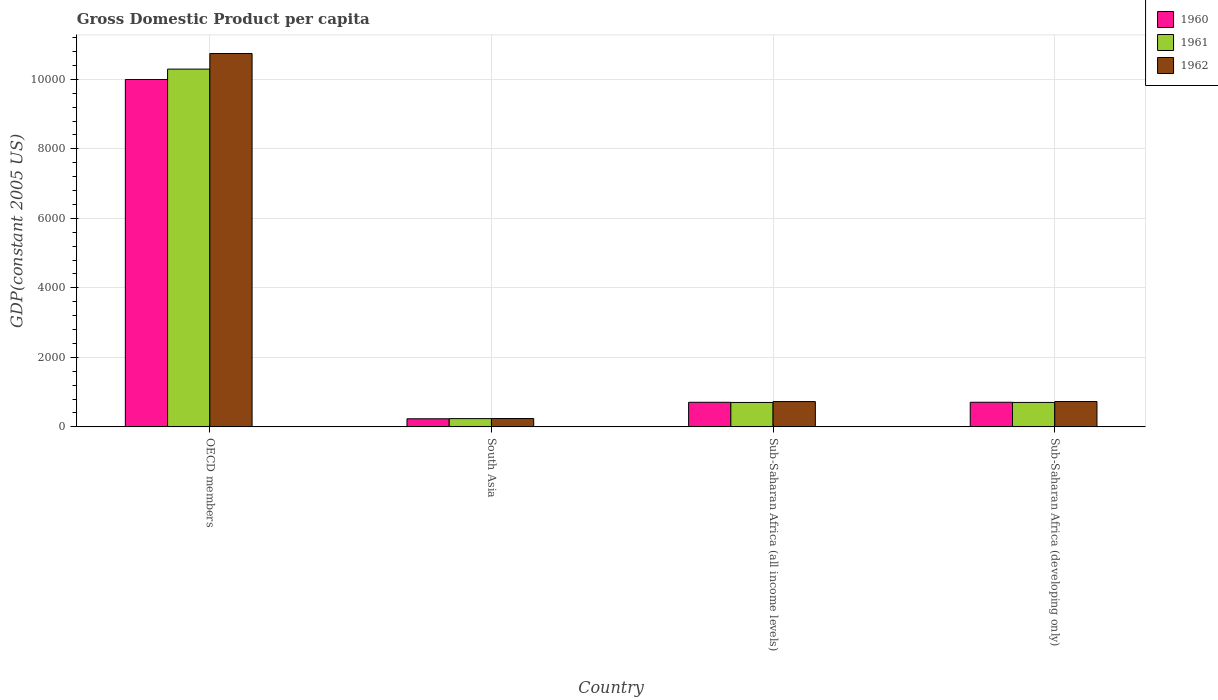Are the number of bars per tick equal to the number of legend labels?
Offer a terse response. Yes. How many bars are there on the 2nd tick from the right?
Provide a short and direct response. 3. In how many cases, is the number of bars for a given country not equal to the number of legend labels?
Provide a short and direct response. 0. What is the GDP per capita in 1962 in OECD members?
Keep it short and to the point. 1.07e+04. Across all countries, what is the maximum GDP per capita in 1962?
Offer a very short reply. 1.07e+04. Across all countries, what is the minimum GDP per capita in 1960?
Provide a short and direct response. 232.78. In which country was the GDP per capita in 1960 minimum?
Provide a succinct answer. South Asia. What is the total GDP per capita in 1960 in the graph?
Your answer should be very brief. 1.16e+04. What is the difference between the GDP per capita in 1962 in South Asia and that in Sub-Saharan Africa (all income levels)?
Your response must be concise. -488. What is the difference between the GDP per capita in 1962 in Sub-Saharan Africa (all income levels) and the GDP per capita in 1960 in South Asia?
Provide a short and direct response. 495.37. What is the average GDP per capita in 1960 per country?
Provide a succinct answer. 2910.89. What is the difference between the GDP per capita of/in 1960 and GDP per capita of/in 1962 in South Asia?
Your response must be concise. -7.37. In how many countries, is the GDP per capita in 1960 greater than 6000 US$?
Your answer should be very brief. 1. What is the ratio of the GDP per capita in 1962 in OECD members to that in South Asia?
Your answer should be very brief. 44.73. Is the difference between the GDP per capita in 1960 in OECD members and South Asia greater than the difference between the GDP per capita in 1962 in OECD members and South Asia?
Provide a short and direct response. No. What is the difference between the highest and the second highest GDP per capita in 1962?
Make the answer very short. -1.00e+04. What is the difference between the highest and the lowest GDP per capita in 1960?
Provide a short and direct response. 9762.55. What does the 2nd bar from the left in South Asia represents?
Provide a short and direct response. 1961. What does the 1st bar from the right in South Asia represents?
Ensure brevity in your answer.  1962. How many bars are there?
Your answer should be very brief. 12. Are all the bars in the graph horizontal?
Offer a very short reply. No. Does the graph contain any zero values?
Ensure brevity in your answer.  No. Where does the legend appear in the graph?
Offer a very short reply. Top right. What is the title of the graph?
Provide a succinct answer. Gross Domestic Product per capita. Does "1978" appear as one of the legend labels in the graph?
Offer a very short reply. No. What is the label or title of the X-axis?
Offer a very short reply. Country. What is the label or title of the Y-axis?
Your answer should be very brief. GDP(constant 2005 US). What is the GDP(constant 2005 US) in 1960 in OECD members?
Offer a very short reply. 9995.33. What is the GDP(constant 2005 US) of 1961 in OECD members?
Your answer should be very brief. 1.03e+04. What is the GDP(constant 2005 US) of 1962 in OECD members?
Keep it short and to the point. 1.07e+04. What is the GDP(constant 2005 US) of 1960 in South Asia?
Your answer should be very brief. 232.78. What is the GDP(constant 2005 US) of 1961 in South Asia?
Keep it short and to the point. 237.38. What is the GDP(constant 2005 US) in 1962 in South Asia?
Provide a short and direct response. 240.15. What is the GDP(constant 2005 US) in 1960 in Sub-Saharan Africa (all income levels)?
Your response must be concise. 707.4. What is the GDP(constant 2005 US) of 1961 in Sub-Saharan Africa (all income levels)?
Your answer should be compact. 702.48. What is the GDP(constant 2005 US) of 1962 in Sub-Saharan Africa (all income levels)?
Offer a terse response. 728.15. What is the GDP(constant 2005 US) of 1960 in Sub-Saharan Africa (developing only)?
Your response must be concise. 708.03. What is the GDP(constant 2005 US) in 1961 in Sub-Saharan Africa (developing only)?
Ensure brevity in your answer.  703.14. What is the GDP(constant 2005 US) of 1962 in Sub-Saharan Africa (developing only)?
Your answer should be very brief. 728.81. Across all countries, what is the maximum GDP(constant 2005 US) in 1960?
Provide a succinct answer. 9995.33. Across all countries, what is the maximum GDP(constant 2005 US) of 1961?
Ensure brevity in your answer.  1.03e+04. Across all countries, what is the maximum GDP(constant 2005 US) of 1962?
Offer a terse response. 1.07e+04. Across all countries, what is the minimum GDP(constant 2005 US) in 1960?
Your answer should be compact. 232.78. Across all countries, what is the minimum GDP(constant 2005 US) in 1961?
Offer a very short reply. 237.38. Across all countries, what is the minimum GDP(constant 2005 US) of 1962?
Offer a very short reply. 240.15. What is the total GDP(constant 2005 US) in 1960 in the graph?
Offer a terse response. 1.16e+04. What is the total GDP(constant 2005 US) in 1961 in the graph?
Make the answer very short. 1.19e+04. What is the total GDP(constant 2005 US) of 1962 in the graph?
Provide a short and direct response. 1.24e+04. What is the difference between the GDP(constant 2005 US) in 1960 in OECD members and that in South Asia?
Ensure brevity in your answer.  9762.55. What is the difference between the GDP(constant 2005 US) of 1961 in OECD members and that in South Asia?
Keep it short and to the point. 1.01e+04. What is the difference between the GDP(constant 2005 US) in 1962 in OECD members and that in South Asia?
Keep it short and to the point. 1.05e+04. What is the difference between the GDP(constant 2005 US) in 1960 in OECD members and that in Sub-Saharan Africa (all income levels)?
Make the answer very short. 9287.92. What is the difference between the GDP(constant 2005 US) in 1961 in OECD members and that in Sub-Saharan Africa (all income levels)?
Give a very brief answer. 9591.46. What is the difference between the GDP(constant 2005 US) of 1962 in OECD members and that in Sub-Saharan Africa (all income levels)?
Your answer should be compact. 1.00e+04. What is the difference between the GDP(constant 2005 US) in 1960 in OECD members and that in Sub-Saharan Africa (developing only)?
Offer a very short reply. 9287.29. What is the difference between the GDP(constant 2005 US) in 1961 in OECD members and that in Sub-Saharan Africa (developing only)?
Offer a very short reply. 9590.8. What is the difference between the GDP(constant 2005 US) in 1962 in OECD members and that in Sub-Saharan Africa (developing only)?
Offer a very short reply. 1.00e+04. What is the difference between the GDP(constant 2005 US) of 1960 in South Asia and that in Sub-Saharan Africa (all income levels)?
Offer a very short reply. -474.62. What is the difference between the GDP(constant 2005 US) in 1961 in South Asia and that in Sub-Saharan Africa (all income levels)?
Make the answer very short. -465.1. What is the difference between the GDP(constant 2005 US) of 1962 in South Asia and that in Sub-Saharan Africa (all income levels)?
Offer a very short reply. -488. What is the difference between the GDP(constant 2005 US) in 1960 in South Asia and that in Sub-Saharan Africa (developing only)?
Offer a terse response. -475.26. What is the difference between the GDP(constant 2005 US) of 1961 in South Asia and that in Sub-Saharan Africa (developing only)?
Ensure brevity in your answer.  -465.76. What is the difference between the GDP(constant 2005 US) in 1962 in South Asia and that in Sub-Saharan Africa (developing only)?
Provide a short and direct response. -488.66. What is the difference between the GDP(constant 2005 US) in 1960 in Sub-Saharan Africa (all income levels) and that in Sub-Saharan Africa (developing only)?
Ensure brevity in your answer.  -0.63. What is the difference between the GDP(constant 2005 US) of 1961 in Sub-Saharan Africa (all income levels) and that in Sub-Saharan Africa (developing only)?
Give a very brief answer. -0.66. What is the difference between the GDP(constant 2005 US) in 1962 in Sub-Saharan Africa (all income levels) and that in Sub-Saharan Africa (developing only)?
Give a very brief answer. -0.66. What is the difference between the GDP(constant 2005 US) in 1960 in OECD members and the GDP(constant 2005 US) in 1961 in South Asia?
Give a very brief answer. 9757.94. What is the difference between the GDP(constant 2005 US) of 1960 in OECD members and the GDP(constant 2005 US) of 1962 in South Asia?
Provide a succinct answer. 9755.17. What is the difference between the GDP(constant 2005 US) of 1961 in OECD members and the GDP(constant 2005 US) of 1962 in South Asia?
Your answer should be very brief. 1.01e+04. What is the difference between the GDP(constant 2005 US) of 1960 in OECD members and the GDP(constant 2005 US) of 1961 in Sub-Saharan Africa (all income levels)?
Make the answer very short. 9292.85. What is the difference between the GDP(constant 2005 US) of 1960 in OECD members and the GDP(constant 2005 US) of 1962 in Sub-Saharan Africa (all income levels)?
Offer a very short reply. 9267.18. What is the difference between the GDP(constant 2005 US) of 1961 in OECD members and the GDP(constant 2005 US) of 1962 in Sub-Saharan Africa (all income levels)?
Give a very brief answer. 9565.79. What is the difference between the GDP(constant 2005 US) of 1960 in OECD members and the GDP(constant 2005 US) of 1961 in Sub-Saharan Africa (developing only)?
Your answer should be very brief. 9292.18. What is the difference between the GDP(constant 2005 US) in 1960 in OECD members and the GDP(constant 2005 US) in 1962 in Sub-Saharan Africa (developing only)?
Your answer should be very brief. 9266.51. What is the difference between the GDP(constant 2005 US) of 1961 in OECD members and the GDP(constant 2005 US) of 1962 in Sub-Saharan Africa (developing only)?
Keep it short and to the point. 9565.13. What is the difference between the GDP(constant 2005 US) in 1960 in South Asia and the GDP(constant 2005 US) in 1961 in Sub-Saharan Africa (all income levels)?
Provide a short and direct response. -469.7. What is the difference between the GDP(constant 2005 US) in 1960 in South Asia and the GDP(constant 2005 US) in 1962 in Sub-Saharan Africa (all income levels)?
Ensure brevity in your answer.  -495.37. What is the difference between the GDP(constant 2005 US) in 1961 in South Asia and the GDP(constant 2005 US) in 1962 in Sub-Saharan Africa (all income levels)?
Offer a very short reply. -490.77. What is the difference between the GDP(constant 2005 US) in 1960 in South Asia and the GDP(constant 2005 US) in 1961 in Sub-Saharan Africa (developing only)?
Your response must be concise. -470.36. What is the difference between the GDP(constant 2005 US) of 1960 in South Asia and the GDP(constant 2005 US) of 1962 in Sub-Saharan Africa (developing only)?
Give a very brief answer. -496.04. What is the difference between the GDP(constant 2005 US) of 1961 in South Asia and the GDP(constant 2005 US) of 1962 in Sub-Saharan Africa (developing only)?
Offer a very short reply. -491.43. What is the difference between the GDP(constant 2005 US) in 1960 in Sub-Saharan Africa (all income levels) and the GDP(constant 2005 US) in 1961 in Sub-Saharan Africa (developing only)?
Offer a very short reply. 4.26. What is the difference between the GDP(constant 2005 US) of 1960 in Sub-Saharan Africa (all income levels) and the GDP(constant 2005 US) of 1962 in Sub-Saharan Africa (developing only)?
Offer a very short reply. -21.41. What is the difference between the GDP(constant 2005 US) of 1961 in Sub-Saharan Africa (all income levels) and the GDP(constant 2005 US) of 1962 in Sub-Saharan Africa (developing only)?
Offer a very short reply. -26.33. What is the average GDP(constant 2005 US) of 1960 per country?
Give a very brief answer. 2910.89. What is the average GDP(constant 2005 US) in 1961 per country?
Offer a terse response. 2984.24. What is the average GDP(constant 2005 US) in 1962 per country?
Your response must be concise. 3109.8. What is the difference between the GDP(constant 2005 US) in 1960 and GDP(constant 2005 US) in 1961 in OECD members?
Keep it short and to the point. -298.62. What is the difference between the GDP(constant 2005 US) of 1960 and GDP(constant 2005 US) of 1962 in OECD members?
Offer a very short reply. -746.74. What is the difference between the GDP(constant 2005 US) in 1961 and GDP(constant 2005 US) in 1962 in OECD members?
Make the answer very short. -448.13. What is the difference between the GDP(constant 2005 US) of 1960 and GDP(constant 2005 US) of 1961 in South Asia?
Offer a very short reply. -4.6. What is the difference between the GDP(constant 2005 US) in 1960 and GDP(constant 2005 US) in 1962 in South Asia?
Keep it short and to the point. -7.37. What is the difference between the GDP(constant 2005 US) of 1961 and GDP(constant 2005 US) of 1962 in South Asia?
Your response must be concise. -2.77. What is the difference between the GDP(constant 2005 US) in 1960 and GDP(constant 2005 US) in 1961 in Sub-Saharan Africa (all income levels)?
Ensure brevity in your answer.  4.92. What is the difference between the GDP(constant 2005 US) of 1960 and GDP(constant 2005 US) of 1962 in Sub-Saharan Africa (all income levels)?
Ensure brevity in your answer.  -20.75. What is the difference between the GDP(constant 2005 US) of 1961 and GDP(constant 2005 US) of 1962 in Sub-Saharan Africa (all income levels)?
Your answer should be very brief. -25.67. What is the difference between the GDP(constant 2005 US) of 1960 and GDP(constant 2005 US) of 1961 in Sub-Saharan Africa (developing only)?
Your answer should be very brief. 4.89. What is the difference between the GDP(constant 2005 US) of 1960 and GDP(constant 2005 US) of 1962 in Sub-Saharan Africa (developing only)?
Ensure brevity in your answer.  -20.78. What is the difference between the GDP(constant 2005 US) in 1961 and GDP(constant 2005 US) in 1962 in Sub-Saharan Africa (developing only)?
Give a very brief answer. -25.67. What is the ratio of the GDP(constant 2005 US) in 1960 in OECD members to that in South Asia?
Ensure brevity in your answer.  42.94. What is the ratio of the GDP(constant 2005 US) in 1961 in OECD members to that in South Asia?
Offer a terse response. 43.36. What is the ratio of the GDP(constant 2005 US) of 1962 in OECD members to that in South Asia?
Give a very brief answer. 44.73. What is the ratio of the GDP(constant 2005 US) of 1960 in OECD members to that in Sub-Saharan Africa (all income levels)?
Provide a short and direct response. 14.13. What is the ratio of the GDP(constant 2005 US) in 1961 in OECD members to that in Sub-Saharan Africa (all income levels)?
Offer a terse response. 14.65. What is the ratio of the GDP(constant 2005 US) of 1962 in OECD members to that in Sub-Saharan Africa (all income levels)?
Offer a very short reply. 14.75. What is the ratio of the GDP(constant 2005 US) in 1960 in OECD members to that in Sub-Saharan Africa (developing only)?
Provide a short and direct response. 14.12. What is the ratio of the GDP(constant 2005 US) in 1961 in OECD members to that in Sub-Saharan Africa (developing only)?
Your response must be concise. 14.64. What is the ratio of the GDP(constant 2005 US) in 1962 in OECD members to that in Sub-Saharan Africa (developing only)?
Give a very brief answer. 14.74. What is the ratio of the GDP(constant 2005 US) of 1960 in South Asia to that in Sub-Saharan Africa (all income levels)?
Your answer should be very brief. 0.33. What is the ratio of the GDP(constant 2005 US) in 1961 in South Asia to that in Sub-Saharan Africa (all income levels)?
Your response must be concise. 0.34. What is the ratio of the GDP(constant 2005 US) of 1962 in South Asia to that in Sub-Saharan Africa (all income levels)?
Keep it short and to the point. 0.33. What is the ratio of the GDP(constant 2005 US) of 1960 in South Asia to that in Sub-Saharan Africa (developing only)?
Ensure brevity in your answer.  0.33. What is the ratio of the GDP(constant 2005 US) in 1961 in South Asia to that in Sub-Saharan Africa (developing only)?
Your answer should be very brief. 0.34. What is the ratio of the GDP(constant 2005 US) of 1962 in South Asia to that in Sub-Saharan Africa (developing only)?
Offer a very short reply. 0.33. What is the ratio of the GDP(constant 2005 US) of 1960 in Sub-Saharan Africa (all income levels) to that in Sub-Saharan Africa (developing only)?
Provide a succinct answer. 1. What is the ratio of the GDP(constant 2005 US) of 1961 in Sub-Saharan Africa (all income levels) to that in Sub-Saharan Africa (developing only)?
Provide a succinct answer. 1. What is the ratio of the GDP(constant 2005 US) of 1962 in Sub-Saharan Africa (all income levels) to that in Sub-Saharan Africa (developing only)?
Give a very brief answer. 1. What is the difference between the highest and the second highest GDP(constant 2005 US) in 1960?
Your response must be concise. 9287.29. What is the difference between the highest and the second highest GDP(constant 2005 US) in 1961?
Offer a very short reply. 9590.8. What is the difference between the highest and the second highest GDP(constant 2005 US) of 1962?
Offer a terse response. 1.00e+04. What is the difference between the highest and the lowest GDP(constant 2005 US) in 1960?
Give a very brief answer. 9762.55. What is the difference between the highest and the lowest GDP(constant 2005 US) in 1961?
Your response must be concise. 1.01e+04. What is the difference between the highest and the lowest GDP(constant 2005 US) in 1962?
Your response must be concise. 1.05e+04. 